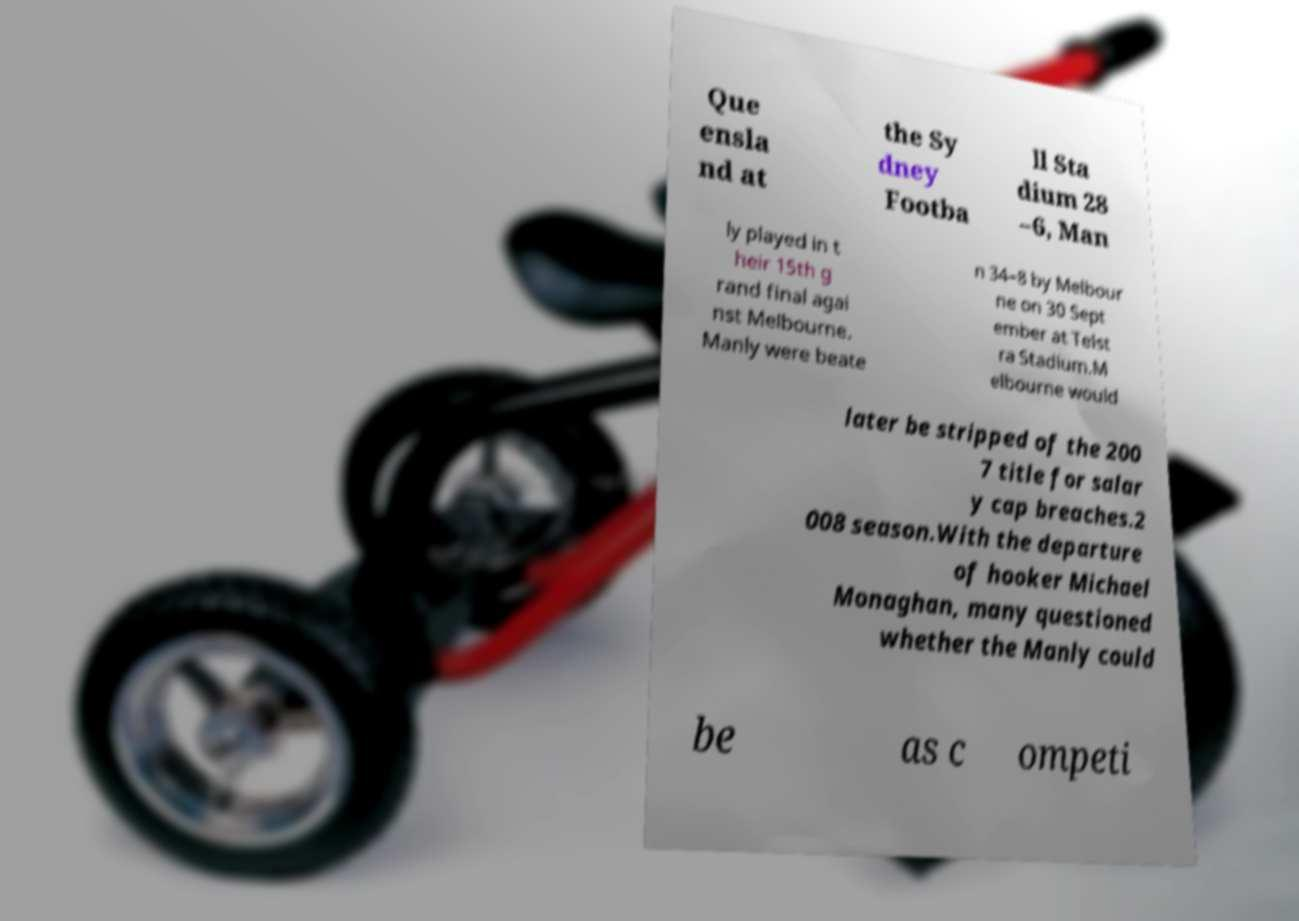Can you read and provide the text displayed in the image?This photo seems to have some interesting text. Can you extract and type it out for me? Que ensla nd at the Sy dney Footba ll Sta dium 28 –6, Man ly played in t heir 15th g rand final agai nst Melbourne. Manly were beate n 34–8 by Melbour ne on 30 Sept ember at Telst ra Stadium.M elbourne would later be stripped of the 200 7 title for salar y cap breaches.2 008 season.With the departure of hooker Michael Monaghan, many questioned whether the Manly could be as c ompeti 